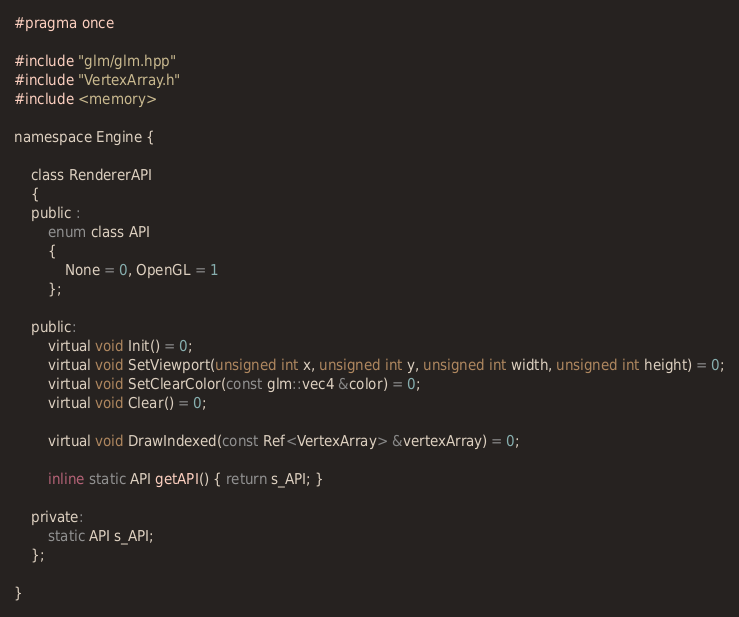Convert code to text. <code><loc_0><loc_0><loc_500><loc_500><_C_>#pragma once

#include "glm/glm.hpp"
#include "VertexArray.h"
#include <memory>

namespace Engine {

	class RendererAPI
	{
	public :
		enum class API
		{
			None = 0, OpenGL = 1
		};

	public:
		virtual void Init() = 0;
		virtual void SetViewport(unsigned int x, unsigned int y, unsigned int width, unsigned int height) = 0;
		virtual void SetClearColor(const glm::vec4 &color) = 0;
		virtual void Clear() = 0;

		virtual void DrawIndexed(const Ref<VertexArray> &vertexArray) = 0;

		inline static API getAPI() { return s_API; }

	private:
		static API s_API;
	};

}</code> 